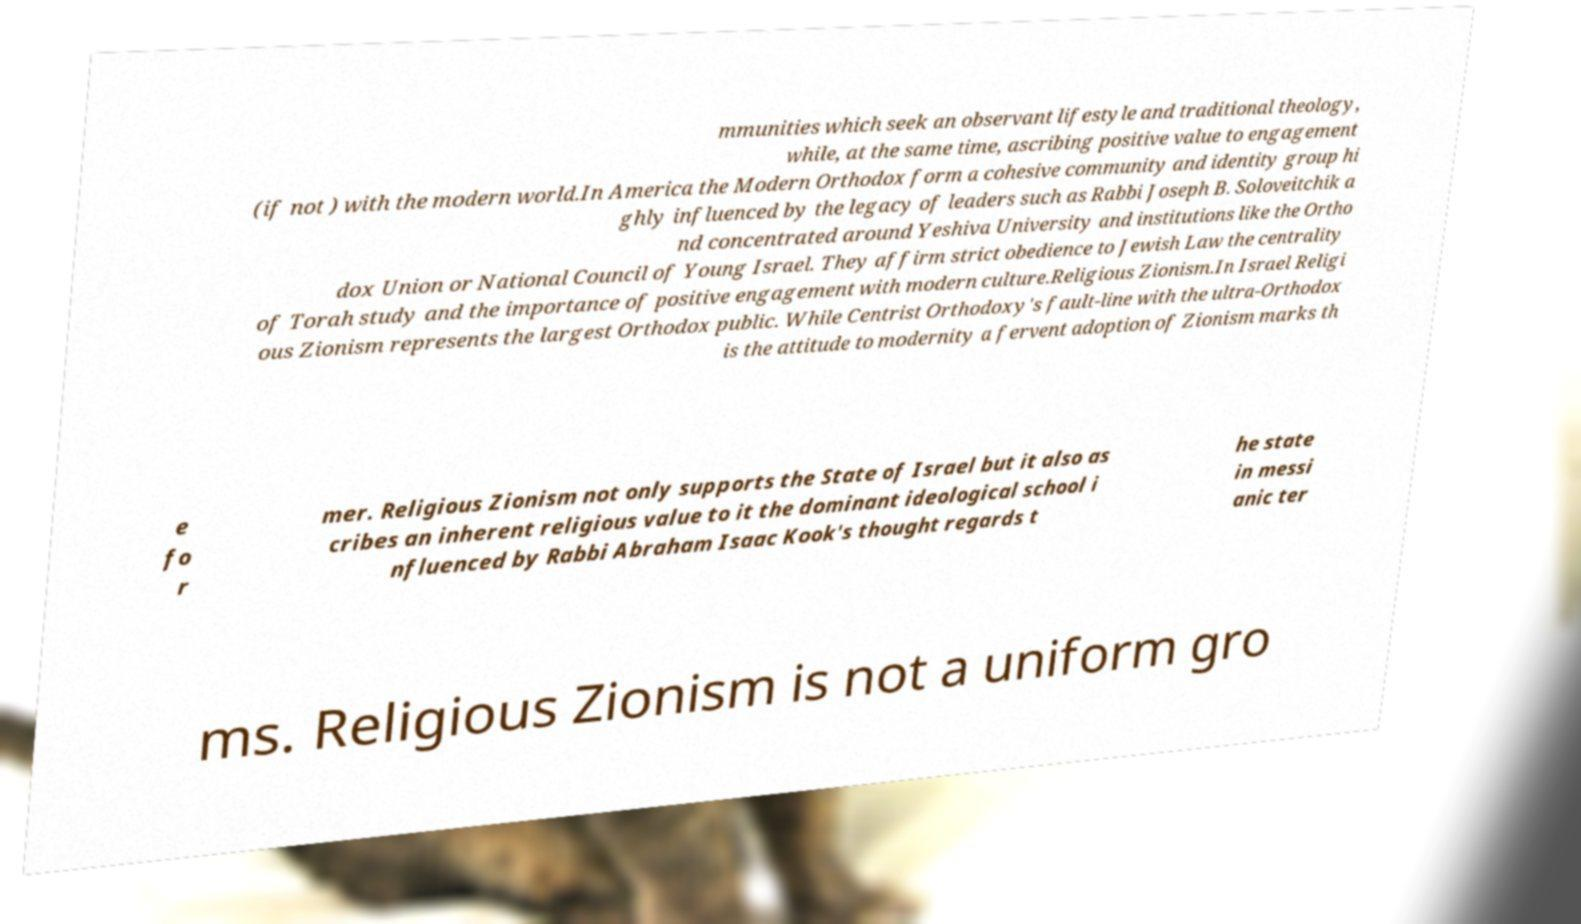Could you extract and type out the text from this image? mmunities which seek an observant lifestyle and traditional theology, while, at the same time, ascribing positive value to engagement (if not ) with the modern world.In America the Modern Orthodox form a cohesive community and identity group hi ghly influenced by the legacy of leaders such as Rabbi Joseph B. Soloveitchik a nd concentrated around Yeshiva University and institutions like the Ortho dox Union or National Council of Young Israel. They affirm strict obedience to Jewish Law the centrality of Torah study and the importance of positive engagement with modern culture.Religious Zionism.In Israel Religi ous Zionism represents the largest Orthodox public. While Centrist Orthodoxy's fault-line with the ultra-Orthodox is the attitude to modernity a fervent adoption of Zionism marks th e fo r mer. Religious Zionism not only supports the State of Israel but it also as cribes an inherent religious value to it the dominant ideological school i nfluenced by Rabbi Abraham Isaac Kook's thought regards t he state in messi anic ter ms. Religious Zionism is not a uniform gro 